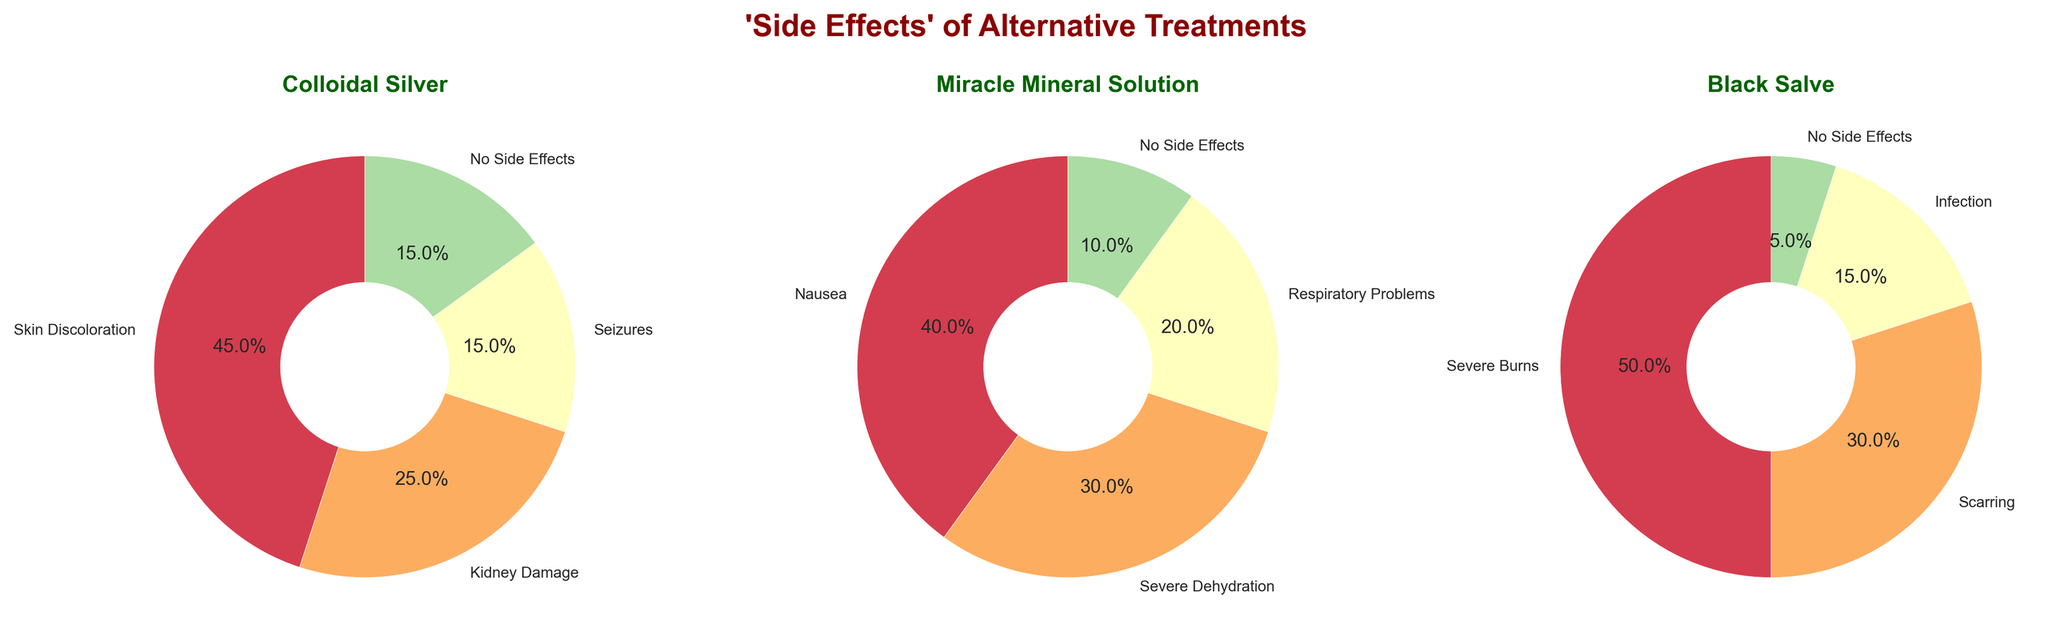What is the title of the figure? The title is written at the top-center of the figure and is prominent with bold formatting and a specific color.
Answer: 'Side Effects' of Alternative Treatments Which treatment has the largest percentage of side effects categorized as "No Side Effects"? Look at each pie chart and identify the segment labeled "No Side Effects" to compare their sizes across the three treatments. Miracle Mineral Solution has the largest slice.
Answer: Miracle Mineral Solution What are the side effects shown for Black Salve and their corresponding percentages? Observe the pie chart labeled 'Black Salve' and note down the segments and their percentages. The side effects and percentages are Severe Burns (50%), Scarring (30%), Infection (15%), and No Side Effects (5%).
Answer: Severe Burns (50%), Scarring (30%), Infection (15%), No Side Effects (5%) Which side effect is the most common among all the treatments? Identify the largest segment in each pie chart and compare them to find out which one has the highest percentage. Severe Burns in Black Salve with 50% is the largest among all.
Answer: Severe Burns (50%) How does the percentage of "Kidney Damage" from Colloidal Silver compare to "Severe Dehydration" from Miracle Mineral Solution? Look at the segments labeled "Kidney Damage" in Colloidal Silver and "Severe Dehydration" in Miracle Mineral Solution and compare their percentages. Kidney Damage is 25% and Severe Dehydration is 30%, so Severe Dehydration is higher.
Answer: Severe Dehydration is higher What is the combined percentage of all side effects (excluding "No Side Effects") for Miracle Mineral Solution? Sum the percentages of all segments in the Miracle Mineral Solution pie chart, excluding the "No Side Effects" segment. The values are Nausea (40%) + Severe Dehydration (30%) + Respiratory Problems (20%) = 90%.
Answer: 90% Rank the treatments in order of the highest percentage of a single side effect to the least. Identify the highest percentage side effect for each treatment: Colloidal Silver (Skin Discoloration 45%), Miracle Mineral Solution (Nausea 40%), Black Salve (Severe Burns 50%). Black Salve (50%) > Colloidal Silver (45%) > Miracle Mineral Solution (40%).
Answer: Black Salve, Colloidal Silver, Miracle Mineral Solution Which treatment has a side effect that matches with its associated percentages sum equating to less than 100%? Check the sum of all side effects for each treatment and identify if any sum up to less than 100%. Colloidal Silver and Black Salve do so because they each include a 15% and 5% "No Side Effects" segment respectively, which makes it easier to verify the total.
Answer: Colloidal Silver and Black Salve 